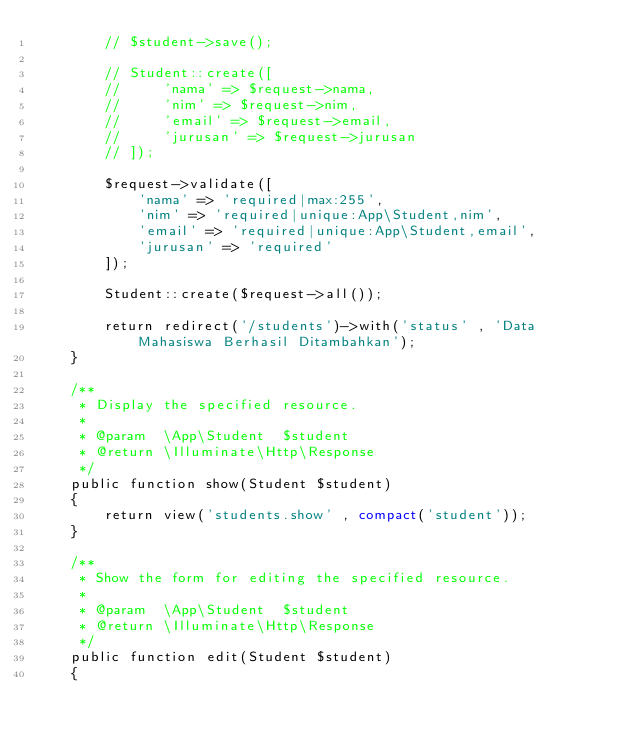Convert code to text. <code><loc_0><loc_0><loc_500><loc_500><_PHP_>        // $student->save();

        // Student::create([
        //     'nama' => $request->nama,
        //     'nim' => $request->nim,
        //     'email' => $request->email,
        //     'jurusan' => $request->jurusan
        // ]);

        $request->validate([
            'nama' => 'required|max:255',
            'nim' => 'required|unique:App\Student,nim',
            'email' => 'required|unique:App\Student,email',
            'jurusan' => 'required'
        ]);

        Student::create($request->all());

        return redirect('/students')->with('status' , 'Data Mahasiswa Berhasil Ditambahkan');
    }

    /**
     * Display the specified resource.
     *
     * @param  \App\Student  $student
     * @return \Illuminate\Http\Response
     */
    public function show(Student $student)
    {
        return view('students.show' , compact('student'));
    }

    /**
     * Show the form for editing the specified resource.
     *
     * @param  \App\Student  $student
     * @return \Illuminate\Http\Response
     */
    public function edit(Student $student)
    {</code> 